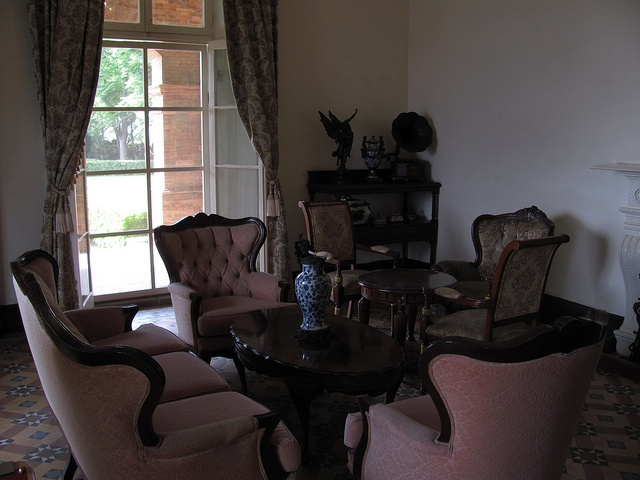Describe the objects in this image and their specific colors. I can see couch in black and gray tones, chair in black and brown tones, dining table in black, navy, and gray tones, couch in black and gray tones, and chair in black and gray tones in this image. 